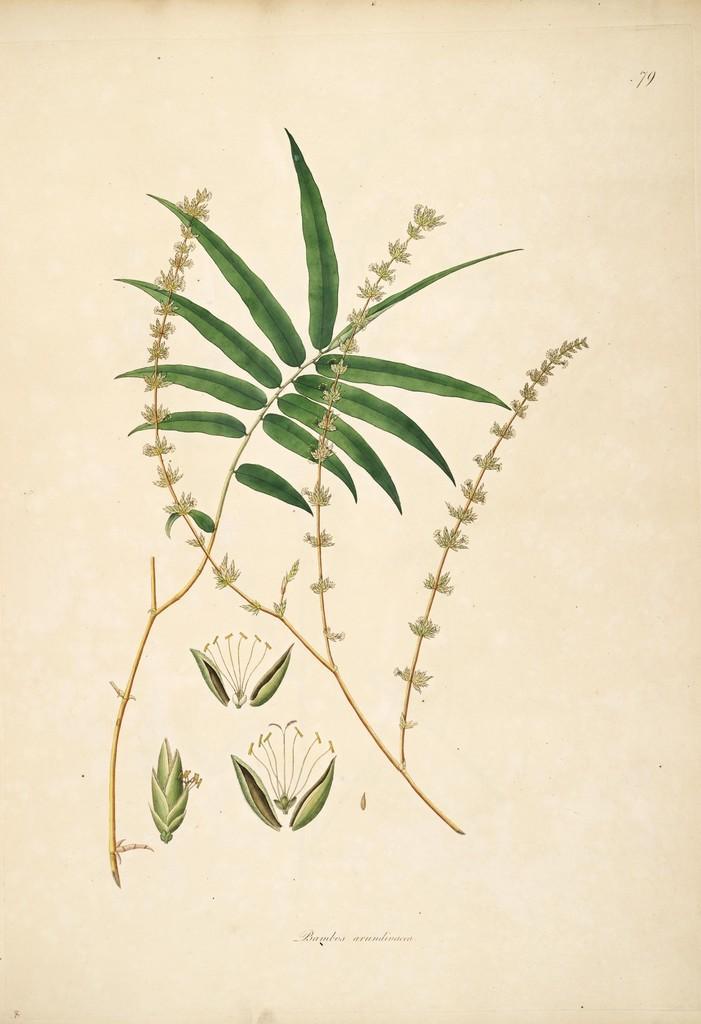In one or two sentences, can you explain what this image depicts? This is a printed picture we see leaves on it. 